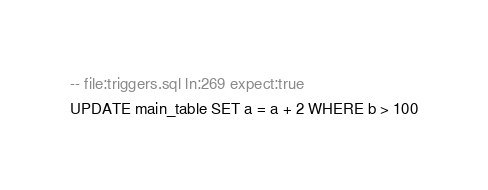<code> <loc_0><loc_0><loc_500><loc_500><_SQL_>-- file:triggers.sql ln:269 expect:true
UPDATE main_table SET a = a + 2 WHERE b > 100
</code> 